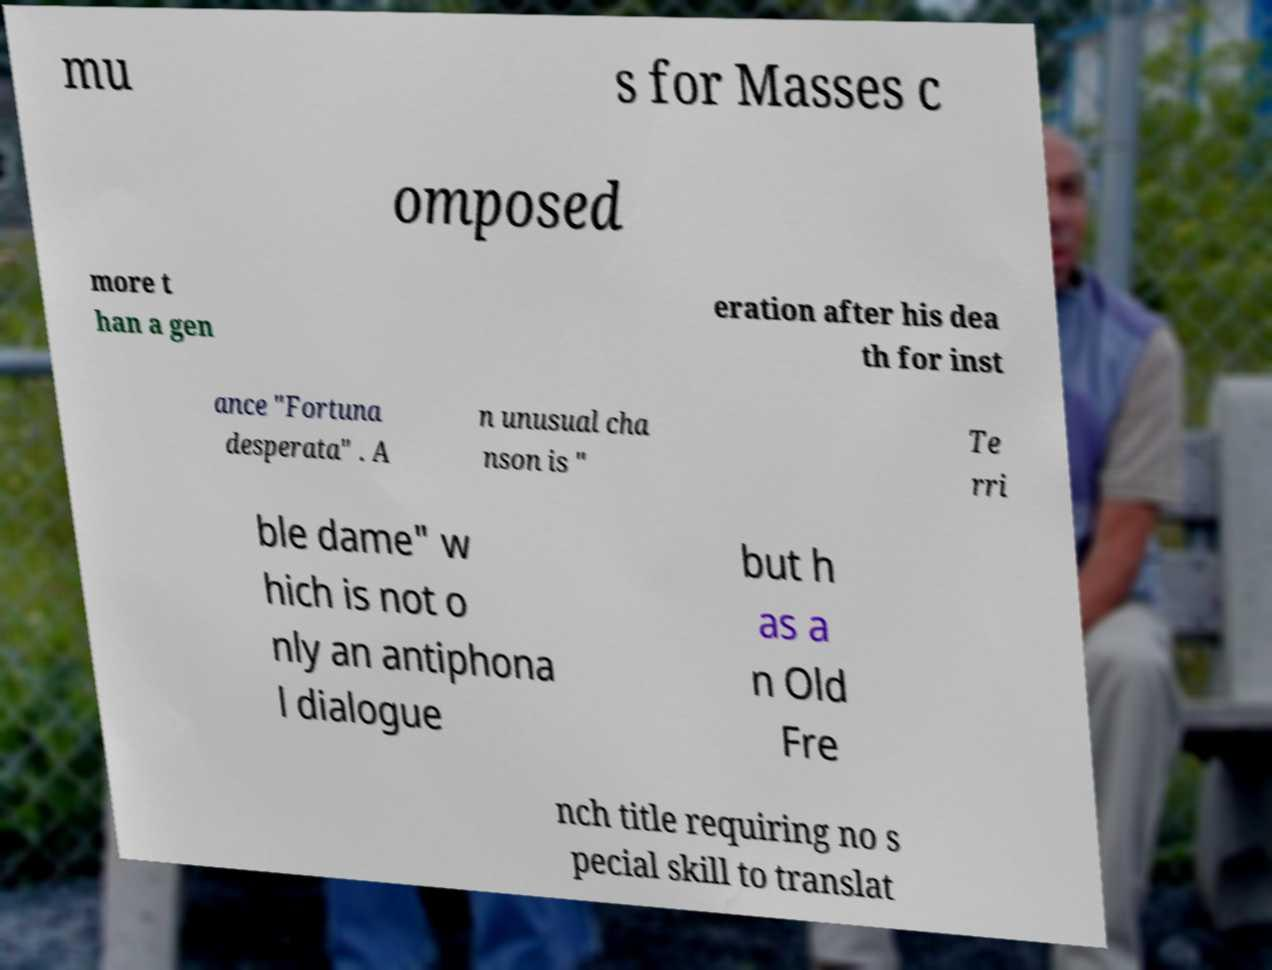Could you assist in decoding the text presented in this image and type it out clearly? mu s for Masses c omposed more t han a gen eration after his dea th for inst ance "Fortuna desperata" . A n unusual cha nson is " Te rri ble dame" w hich is not o nly an antiphona l dialogue but h as a n Old Fre nch title requiring no s pecial skill to translat 